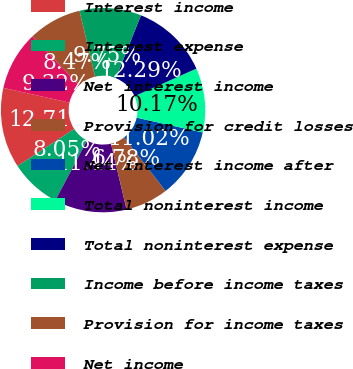<chart> <loc_0><loc_0><loc_500><loc_500><pie_chart><fcel>Interest income<fcel>Interest expense<fcel>Net interest income<fcel>Provision for credit losses<fcel>Net interest income after<fcel>Total noninterest income<fcel>Total noninterest expense<fcel>Income before income taxes<fcel>Provision for income taxes<fcel>Net income<nl><fcel>12.71%<fcel>8.05%<fcel>11.44%<fcel>6.78%<fcel>11.02%<fcel>10.17%<fcel>12.29%<fcel>9.75%<fcel>8.47%<fcel>9.32%<nl></chart> 